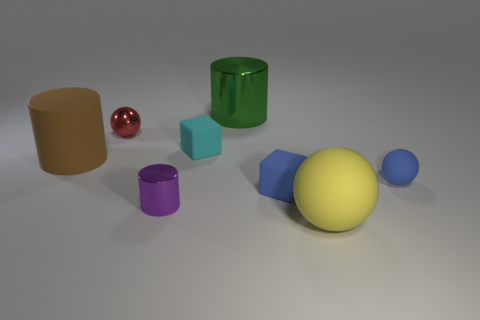Subtract all matte cylinders. How many cylinders are left? 2 Add 2 small cyan cubes. How many objects exist? 10 Subtract all brown cylinders. How many cylinders are left? 2 Add 2 big green balls. How many big green balls exist? 2 Subtract 1 blue balls. How many objects are left? 7 Subtract all cylinders. How many objects are left? 5 Subtract 2 balls. How many balls are left? 1 Subtract all blue cylinders. Subtract all yellow spheres. How many cylinders are left? 3 Subtract all yellow blocks. How many purple cylinders are left? 1 Subtract all gray metallic cylinders. Subtract all purple cylinders. How many objects are left? 7 